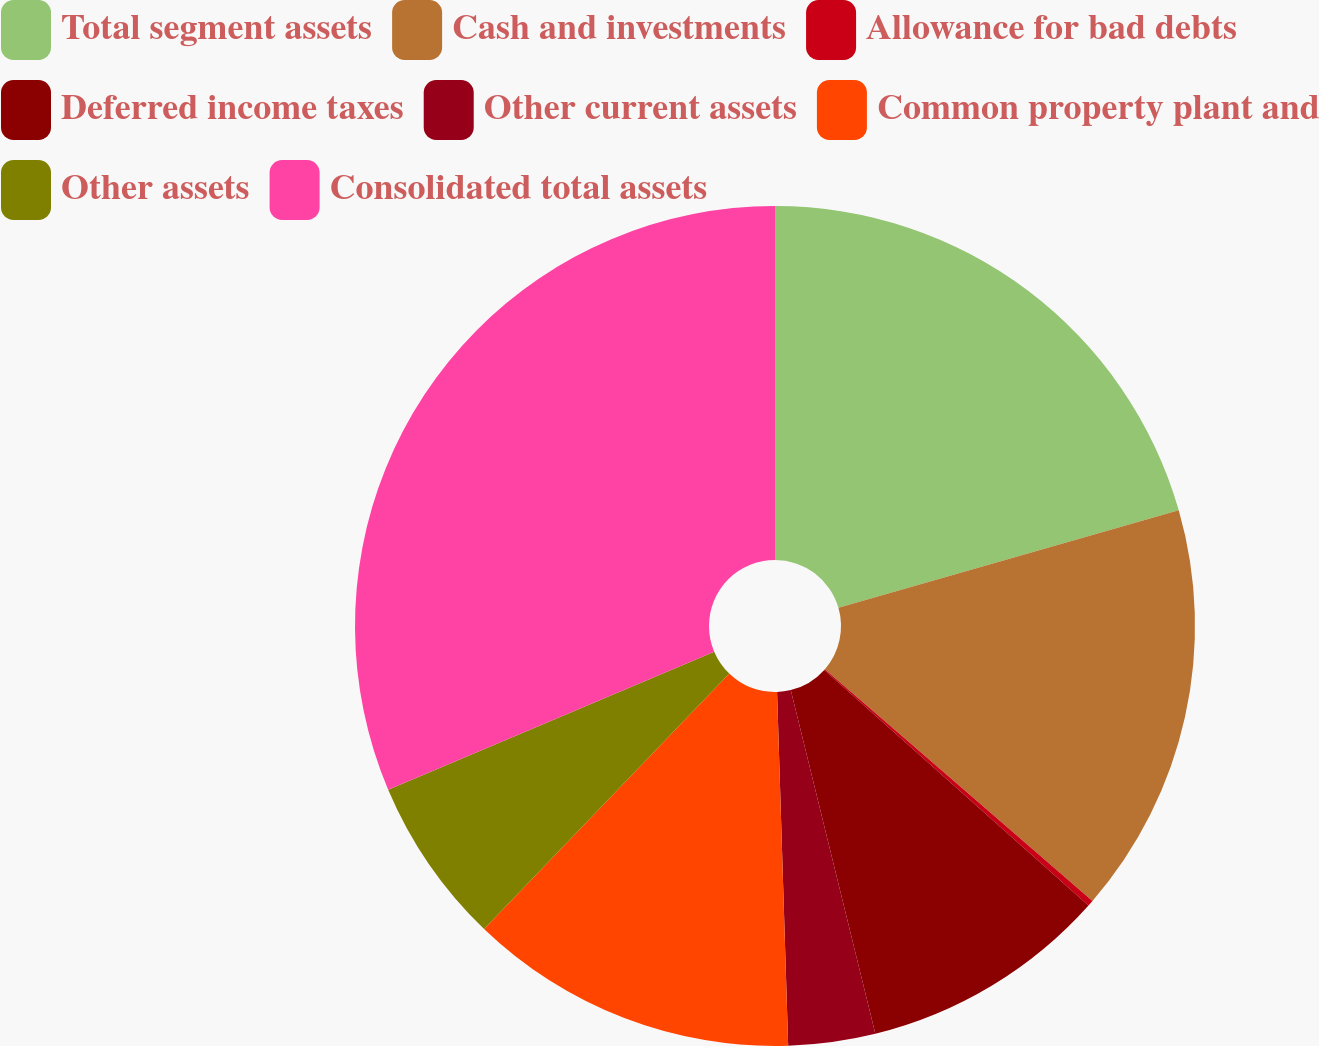Convert chart. <chart><loc_0><loc_0><loc_500><loc_500><pie_chart><fcel>Total segment assets<fcel>Cash and investments<fcel>Allowance for bad debts<fcel>Deferred income taxes<fcel>Other current assets<fcel>Common property plant and<fcel>Other assets<fcel>Consolidated total assets<nl><fcel>20.56%<fcel>15.8%<fcel>0.23%<fcel>9.57%<fcel>3.34%<fcel>12.68%<fcel>6.45%<fcel>31.37%<nl></chart> 